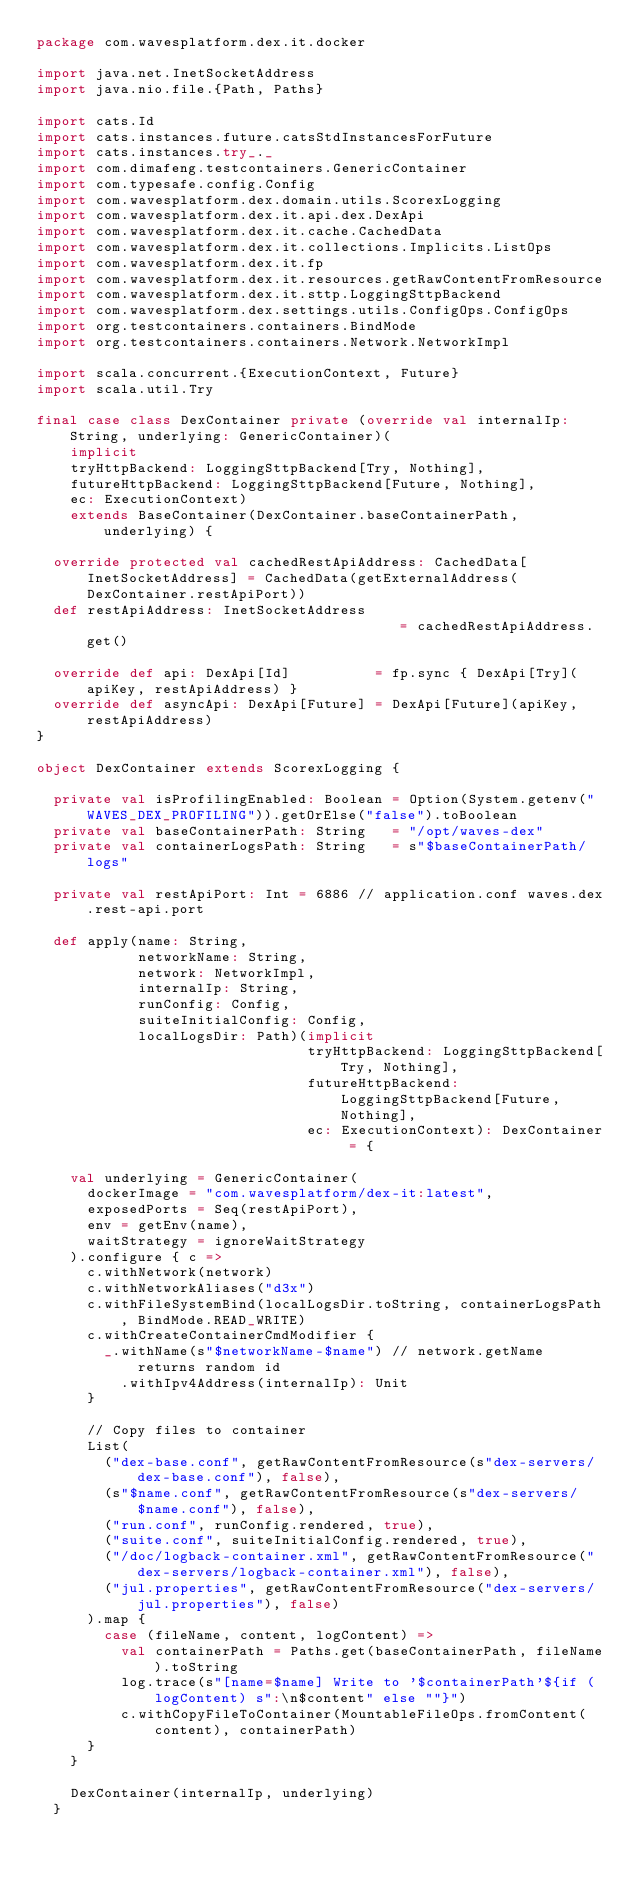Convert code to text. <code><loc_0><loc_0><loc_500><loc_500><_Scala_>package com.wavesplatform.dex.it.docker

import java.net.InetSocketAddress
import java.nio.file.{Path, Paths}

import cats.Id
import cats.instances.future.catsStdInstancesForFuture
import cats.instances.try_._
import com.dimafeng.testcontainers.GenericContainer
import com.typesafe.config.Config
import com.wavesplatform.dex.domain.utils.ScorexLogging
import com.wavesplatform.dex.it.api.dex.DexApi
import com.wavesplatform.dex.it.cache.CachedData
import com.wavesplatform.dex.it.collections.Implicits.ListOps
import com.wavesplatform.dex.it.fp
import com.wavesplatform.dex.it.resources.getRawContentFromResource
import com.wavesplatform.dex.it.sttp.LoggingSttpBackend
import com.wavesplatform.dex.settings.utils.ConfigOps.ConfigOps
import org.testcontainers.containers.BindMode
import org.testcontainers.containers.Network.NetworkImpl

import scala.concurrent.{ExecutionContext, Future}
import scala.util.Try

final case class DexContainer private (override val internalIp: String, underlying: GenericContainer)(
    implicit
    tryHttpBackend: LoggingSttpBackend[Try, Nothing],
    futureHttpBackend: LoggingSttpBackend[Future, Nothing],
    ec: ExecutionContext)
    extends BaseContainer(DexContainer.baseContainerPath, underlying) {

  override protected val cachedRestApiAddress: CachedData[InetSocketAddress] = CachedData(getExternalAddress(DexContainer.restApiPort))
  def restApiAddress: InetSocketAddress                                      = cachedRestApiAddress.get()

  override def api: DexApi[Id]          = fp.sync { DexApi[Try](apiKey, restApiAddress) }
  override def asyncApi: DexApi[Future] = DexApi[Future](apiKey, restApiAddress)
}

object DexContainer extends ScorexLogging {

  private val isProfilingEnabled: Boolean = Option(System.getenv("WAVES_DEX_PROFILING")).getOrElse("false").toBoolean
  private val baseContainerPath: String   = "/opt/waves-dex"
  private val containerLogsPath: String   = s"$baseContainerPath/logs"

  private val restApiPort: Int = 6886 // application.conf waves.dex.rest-api.port

  def apply(name: String,
            networkName: String,
            network: NetworkImpl,
            internalIp: String,
            runConfig: Config,
            suiteInitialConfig: Config,
            localLogsDir: Path)(implicit
                                tryHttpBackend: LoggingSttpBackend[Try, Nothing],
                                futureHttpBackend: LoggingSttpBackend[Future, Nothing],
                                ec: ExecutionContext): DexContainer = {

    val underlying = GenericContainer(
      dockerImage = "com.wavesplatform/dex-it:latest",
      exposedPorts = Seq(restApiPort),
      env = getEnv(name),
      waitStrategy = ignoreWaitStrategy
    ).configure { c =>
      c.withNetwork(network)
      c.withNetworkAliases("d3x")
      c.withFileSystemBind(localLogsDir.toString, containerLogsPath, BindMode.READ_WRITE)
      c.withCreateContainerCmdModifier {
        _.withName(s"$networkName-$name") // network.getName returns random id
          .withIpv4Address(internalIp): Unit
      }

      // Copy files to container
      List(
        ("dex-base.conf", getRawContentFromResource(s"dex-servers/dex-base.conf"), false),
        (s"$name.conf", getRawContentFromResource(s"dex-servers/$name.conf"), false),
        ("run.conf", runConfig.rendered, true),
        ("suite.conf", suiteInitialConfig.rendered, true),
        ("/doc/logback-container.xml", getRawContentFromResource("dex-servers/logback-container.xml"), false),
        ("jul.properties", getRawContentFromResource("dex-servers/jul.properties"), false)
      ).map {
        case (fileName, content, logContent) =>
          val containerPath = Paths.get(baseContainerPath, fileName).toString
          log.trace(s"[name=$name] Write to '$containerPath'${if (logContent) s":\n$content" else ""}")
          c.withCopyFileToContainer(MountableFileOps.fromContent(content), containerPath)
      }
    }

    DexContainer(internalIp, underlying)
  }
</code> 